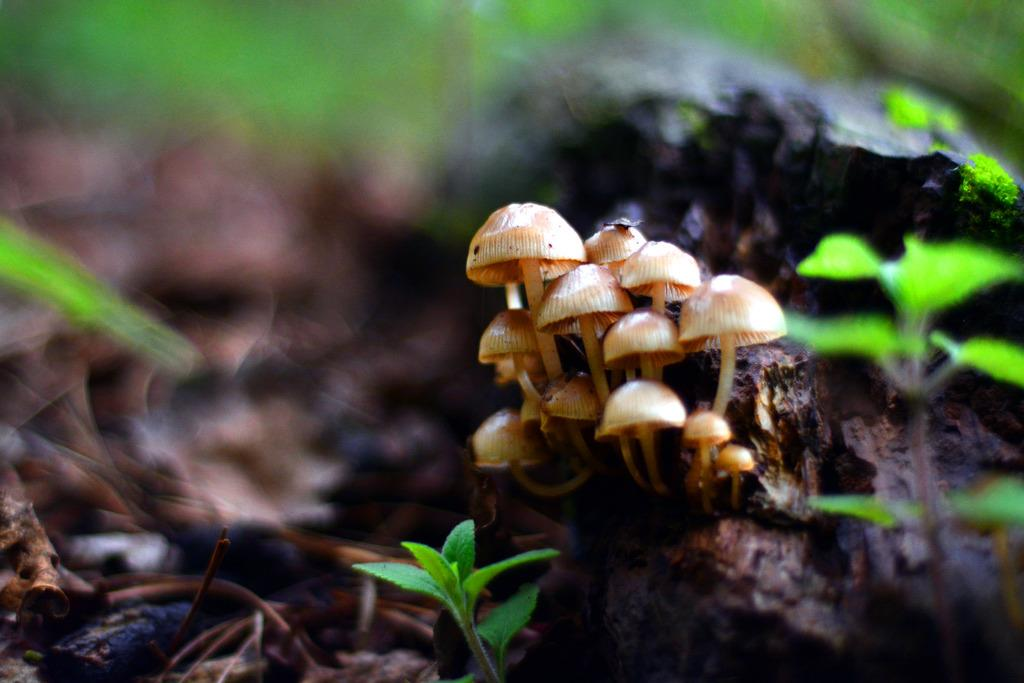What type of vegetation can be seen in the image? There are mushrooms and small plants with leaves in the image. What is present on the floor in the image? Dry leaves are present on the floor in the image. What type of ice can be seen melting on the calculator in the image? There is no ice or calculator present in the image. 